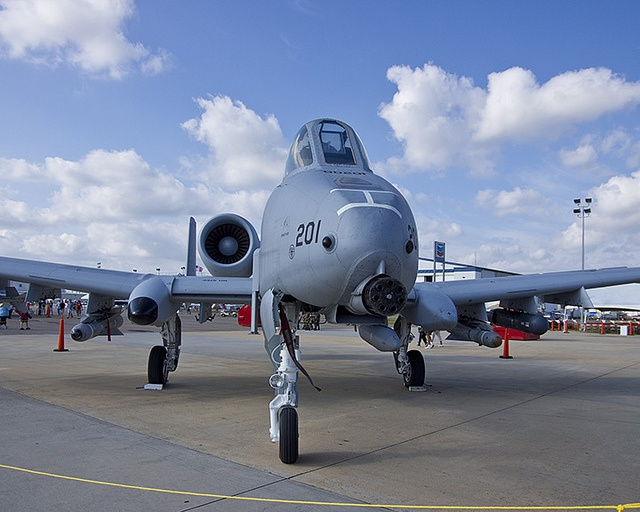Describe the objects in this image and their specific colors. I can see airplane in lavender, black, and gray tones, people in lavender, black, blue, gray, and navy tones, people in lavender, black, navy, gray, and maroon tones, people in lavender, black, maroon, gray, and navy tones, and people in lavender, gray, darkgray, and black tones in this image. 